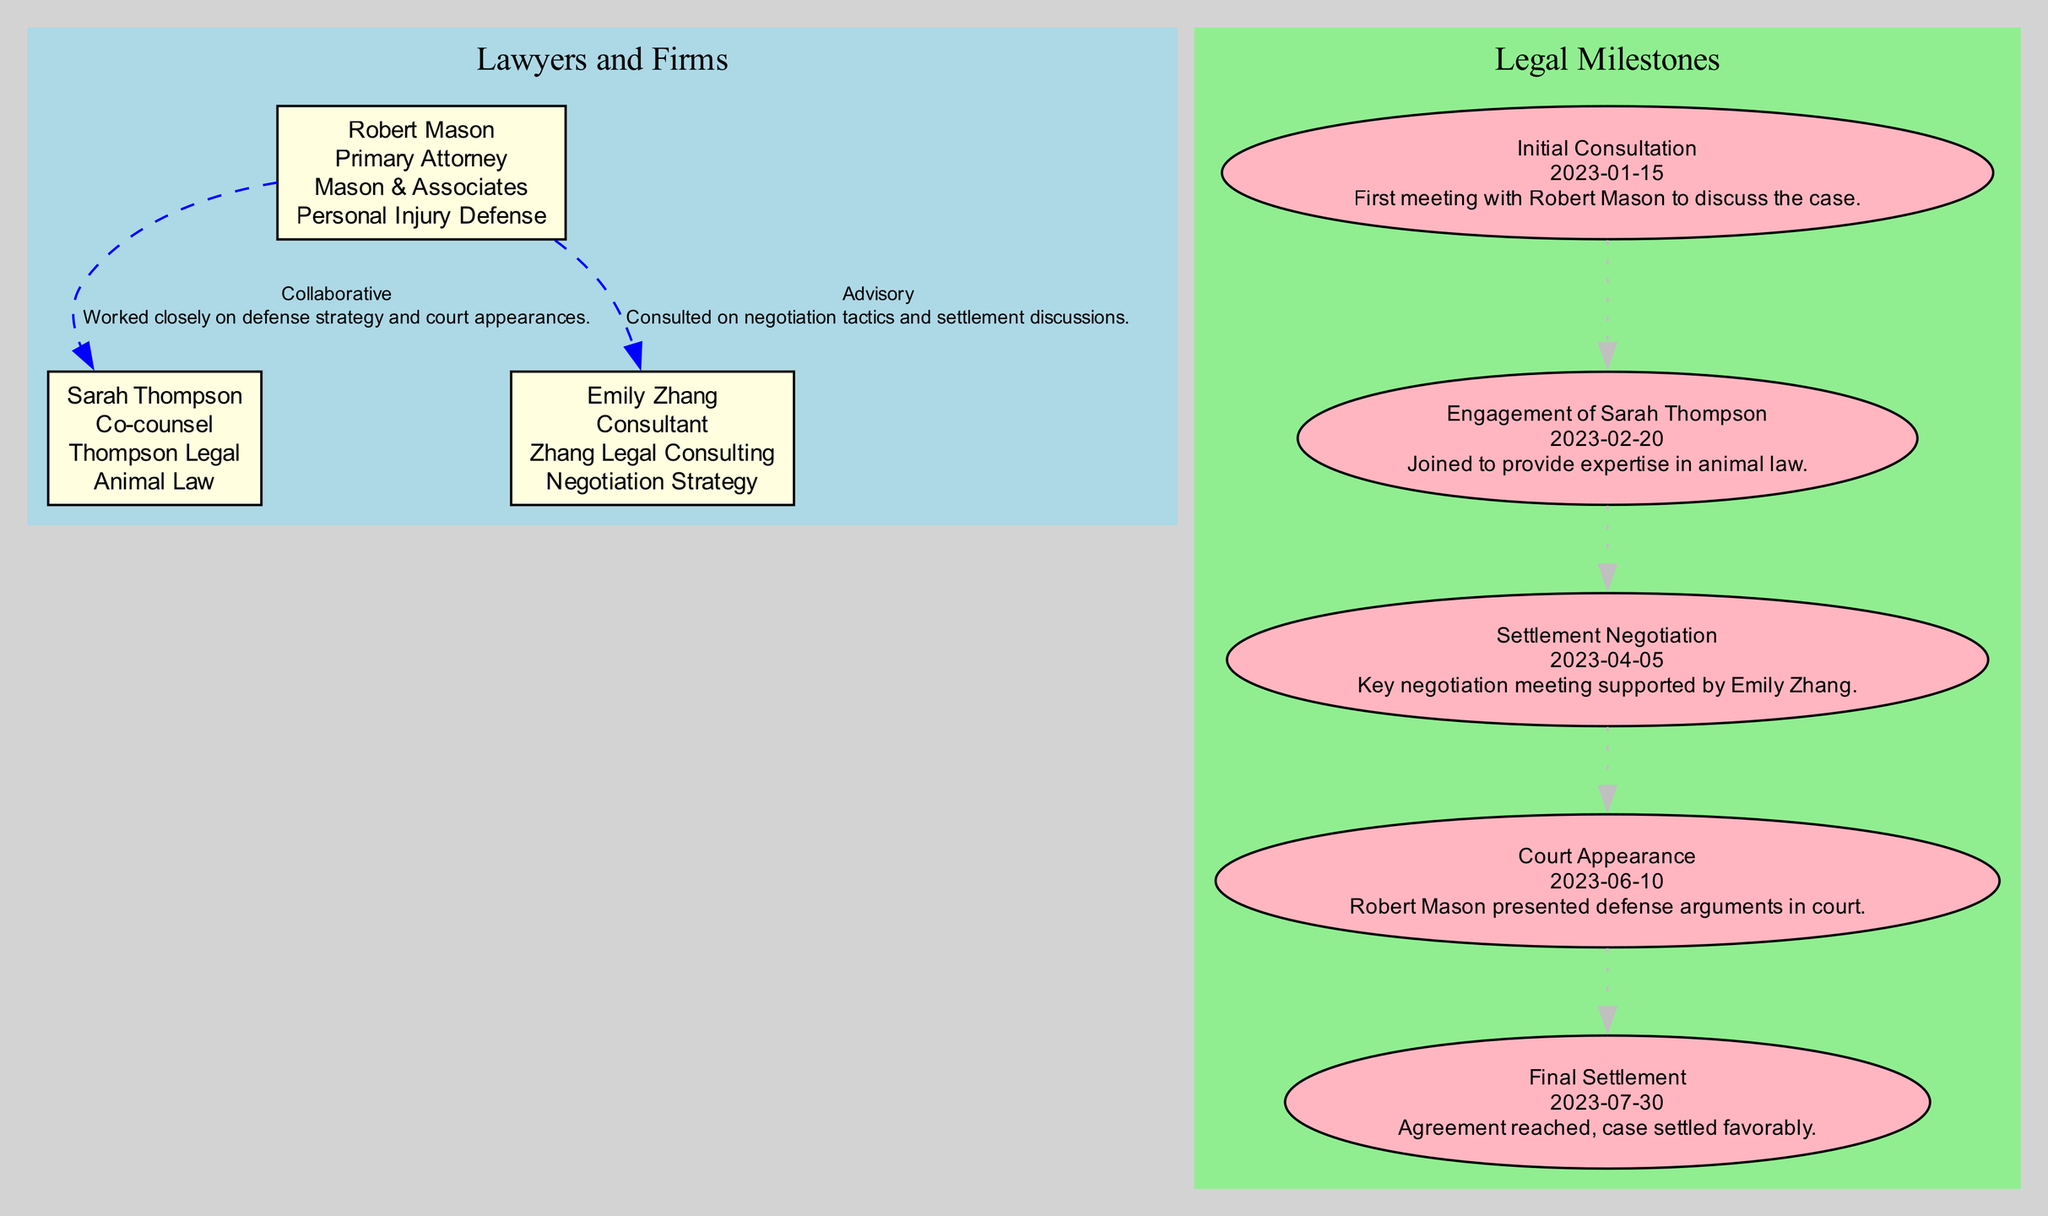What is the position of Robert Mason? The diagram indicates that Robert Mason is the Primary Attorney. This information can be located within his node in the "Lawyers and Firms" section of the diagram.
Answer: Primary Attorney Which law firm does Emily Zhang belong to? According to the diagram, Emily Zhang is associated with Zhang Legal Consulting. This can be found in her node under the "Lawyers and Firms" section.
Answer: Zhang Legal Consulting What type of law does Sarah Thompson specialize in? In the diagram, it's specified that Sarah Thompson specializes in Animal Law. This detail is clearly indicated in her respective node.
Answer: Animal Law How many legal milestones are shown in the diagram? By counting the nodes in the "Legal Milestones" section, it is determined that there are five milestones listed, indicating the significant events in the litigation process.
Answer: 5 What relationship type exists between Robert Mason and Sarah Thompson? The diagram describes their relationship as "Collaborative," with the specific nature detailed in the connection between their nodes in the Key Relationships section.
Answer: Collaborative Which date marks the initial consultation? The diagram states that the initial consultation occurred on January 15, 2023. This information is listed clearly in the "Legal Milestones" section under the relevant event.
Answer: 2023-01-15 How did Emily Zhang contribute to the case? The diagram indicates that Emily Zhang provided advisory support specifically focusing on negotiation tactics and settlement discussions, as noted in the Key Relationships section.
Answer: Advisory What was the outcome of the court appearance on June 10, 2023? According to the "Legal Milestones" in the diagram, the court appearance involved Robert Mason presenting defense arguments, which signifies an active engagement in the litigation process.
Answer: Presented defense arguments What was the result of the final settlement? The diagram states that the case was settled favorably on July 30, 2023, indicating a positive outcome for the involved parties. This can be found in the "Legal Milestones" section.
Answer: Settled favorably 